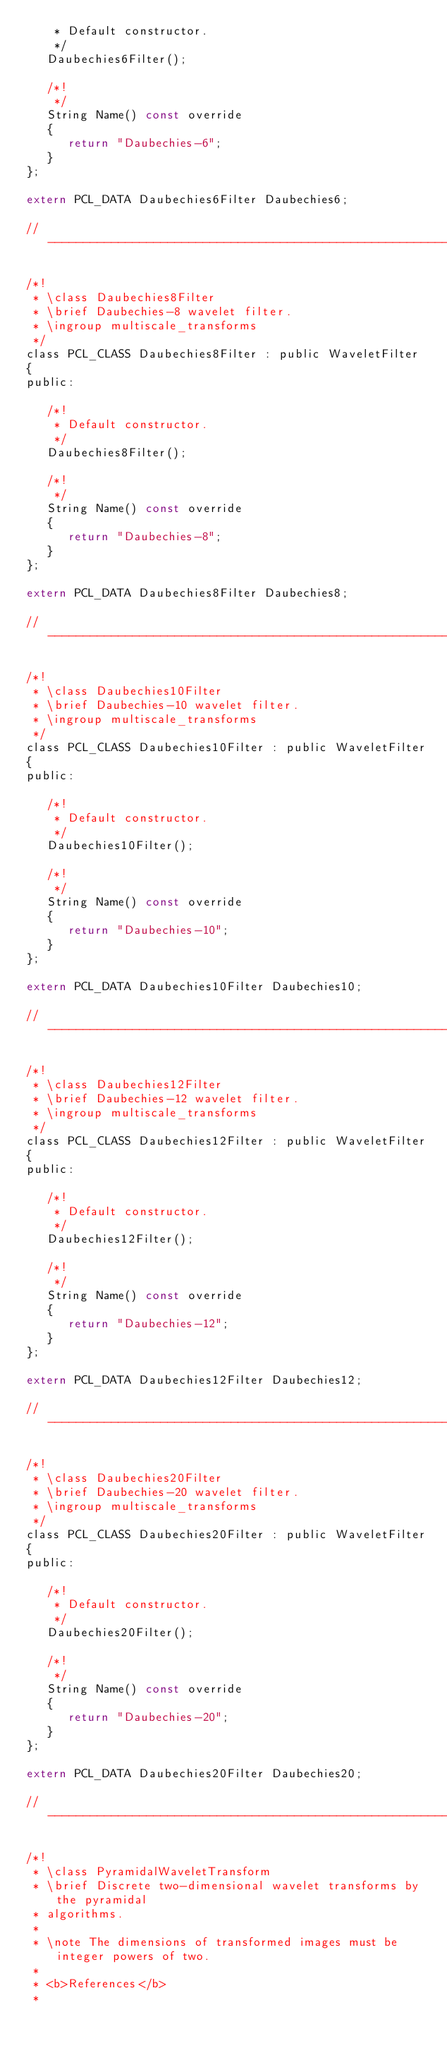<code> <loc_0><loc_0><loc_500><loc_500><_C_>    * Default constructor.
    */
   Daubechies6Filter();

   /*!
    */
   String Name() const override
   {
      return "Daubechies-6";
   }
};

extern PCL_DATA Daubechies6Filter Daubechies6;

// ----------------------------------------------------------------------------

/*!
 * \class Daubechies8Filter
 * \brief Daubechies-8 wavelet filter.
 * \ingroup multiscale_transforms
 */
class PCL_CLASS Daubechies8Filter : public WaveletFilter
{
public:

   /*!
    * Default constructor.
    */
   Daubechies8Filter();

   /*!
    */
   String Name() const override
   {
      return "Daubechies-8";
   }
};

extern PCL_DATA Daubechies8Filter Daubechies8;

// ----------------------------------------------------------------------------

/*!
 * \class Daubechies10Filter
 * \brief Daubechies-10 wavelet filter.
 * \ingroup multiscale_transforms
 */
class PCL_CLASS Daubechies10Filter : public WaveletFilter
{
public:

   /*!
    * Default constructor.
    */
   Daubechies10Filter();

   /*!
    */
   String Name() const override
   {
      return "Daubechies-10";
   }
};

extern PCL_DATA Daubechies10Filter Daubechies10;

// ----------------------------------------------------------------------------

/*!
 * \class Daubechies12Filter
 * \brief Daubechies-12 wavelet filter.
 * \ingroup multiscale_transforms
 */
class PCL_CLASS Daubechies12Filter : public WaveletFilter
{
public:

   /*!
    * Default constructor.
    */
   Daubechies12Filter();

   /*!
    */
   String Name() const override
   {
      return "Daubechies-12";
   }
};

extern PCL_DATA Daubechies12Filter Daubechies12;

// ----------------------------------------------------------------------------

/*!
 * \class Daubechies20Filter
 * \brief Daubechies-20 wavelet filter.
 * \ingroup multiscale_transforms
 */
class PCL_CLASS Daubechies20Filter : public WaveletFilter
{
public:

   /*!
    * Default constructor.
    */
   Daubechies20Filter();

   /*!
    */
   String Name() const override
   {
      return "Daubechies-20";
   }
};

extern PCL_DATA Daubechies20Filter Daubechies20;

// ----------------------------------------------------------------------------

/*!
 * \class PyramidalWaveletTransform
 * \brief Discrete two-dimensional wavelet transforms by the pyramidal
 * algorithms.
 *
 * \note The dimensions of transformed images must be integer powers of two.
 *
 * <b>References</b>
 *</code> 